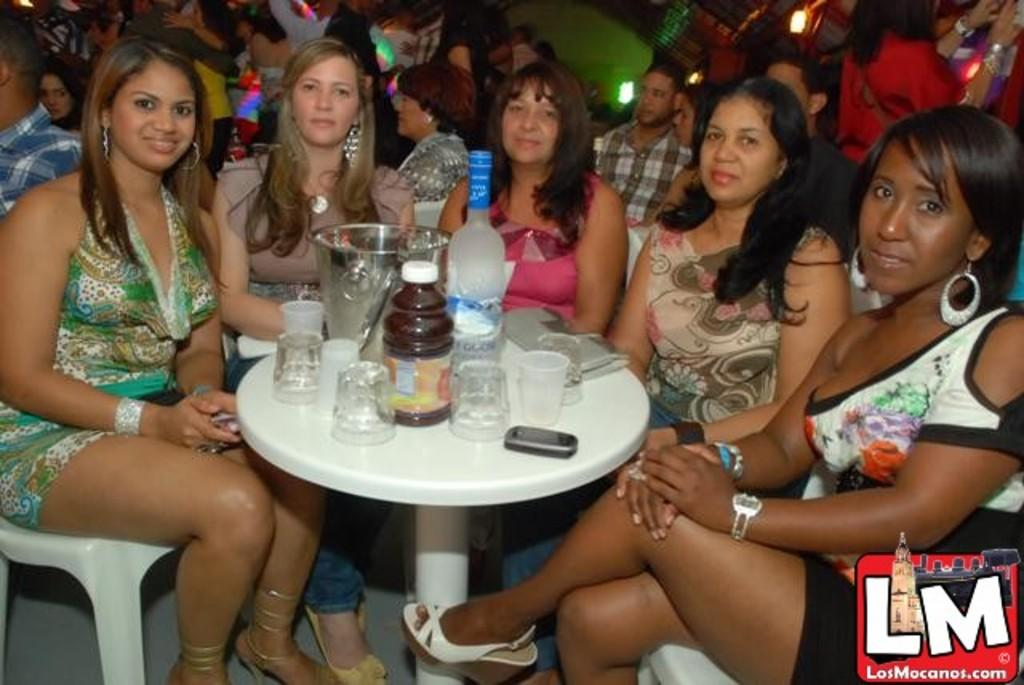Who is present in the image? There are people in the image. Can you describe the gender of some of the individuals? Some of the people are women. What are the women doing in the image? The women are sitting on chairs. What is on the table in the image? There are glasses and a bottle on the table. What type of fowl can be seen sitting on the chair next to the woman? There is no fowl present in the image; only people are visible. Can you describe the spot on the table where the bottle is placed? The image does not provide information about the specific spot on the table where the bottle is placed, only that it is on the table. 